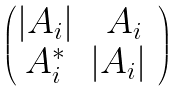<formula> <loc_0><loc_0><loc_500><loc_500>\begin{pmatrix} | A _ { i } | & A _ { i } \\ A ^ { * } _ { i } & | A _ { i } | \ \end{pmatrix}</formula> 